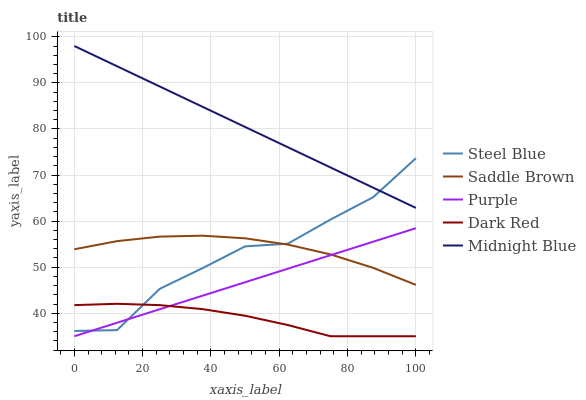Does Dark Red have the minimum area under the curve?
Answer yes or no. Yes. Does Midnight Blue have the maximum area under the curve?
Answer yes or no. Yes. Does Midnight Blue have the minimum area under the curve?
Answer yes or no. No. Does Dark Red have the maximum area under the curve?
Answer yes or no. No. Is Purple the smoothest?
Answer yes or no. Yes. Is Steel Blue the roughest?
Answer yes or no. Yes. Is Dark Red the smoothest?
Answer yes or no. No. Is Dark Red the roughest?
Answer yes or no. No. Does Purple have the lowest value?
Answer yes or no. Yes. Does Midnight Blue have the lowest value?
Answer yes or no. No. Does Midnight Blue have the highest value?
Answer yes or no. Yes. Does Dark Red have the highest value?
Answer yes or no. No. Is Purple less than Midnight Blue?
Answer yes or no. Yes. Is Saddle Brown greater than Dark Red?
Answer yes or no. Yes. Does Purple intersect Steel Blue?
Answer yes or no. Yes. Is Purple less than Steel Blue?
Answer yes or no. No. Is Purple greater than Steel Blue?
Answer yes or no. No. Does Purple intersect Midnight Blue?
Answer yes or no. No. 